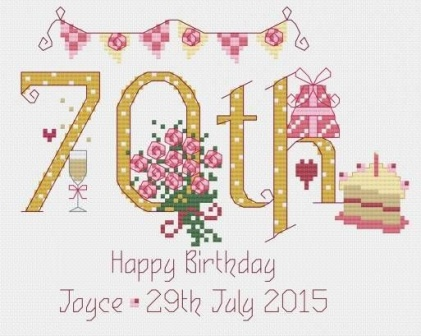What details in the image suggest it is a special occasion? This image is rich with details suggesting a special occasion, primarily a 70th birthday celebration. Key indicators include the '70th' on the banner, symbolizing a milestone age. Additionally, the words 'Happy Birthday Joyce - 29th July 2015' personalize the event, making it unique to the individual celebrated. Surrounding decorations like bouquets of flowers and a slice of cake further underscore the festive nature of the event, commonly associated with birthday parties. 